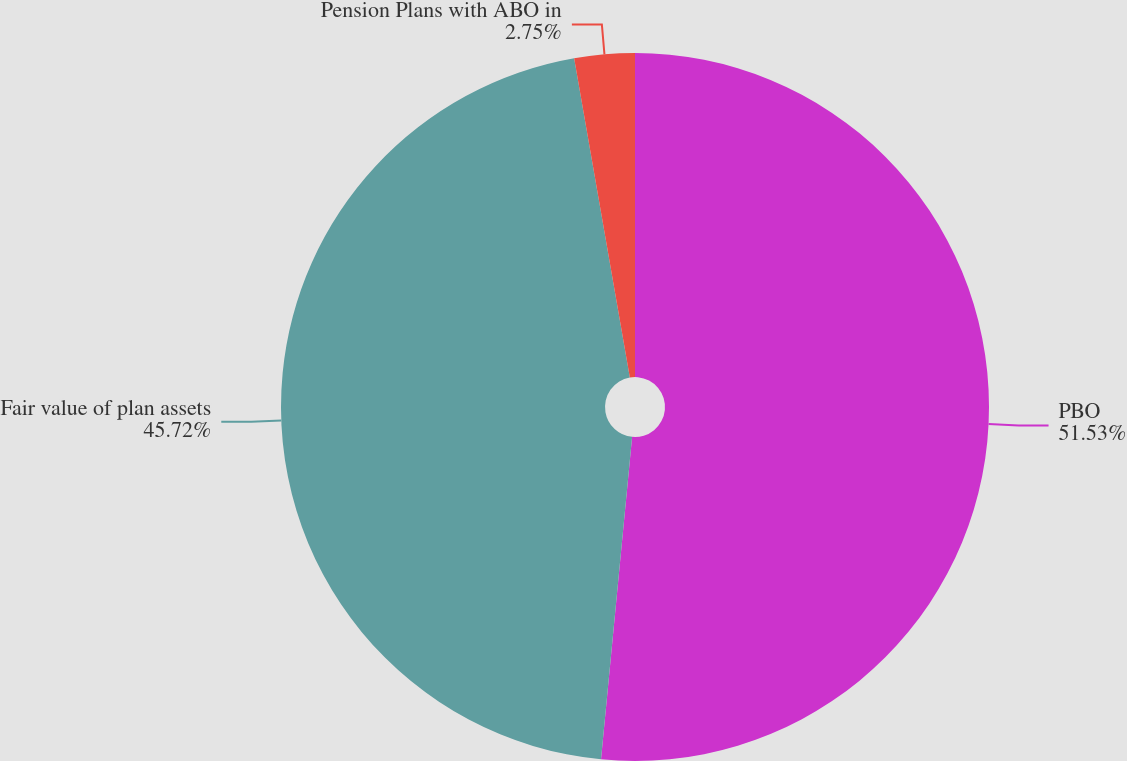Convert chart to OTSL. <chart><loc_0><loc_0><loc_500><loc_500><pie_chart><fcel>PBO<fcel>Fair value of plan assets<fcel>Pension Plans with ABO in<nl><fcel>51.53%<fcel>45.72%<fcel>2.75%<nl></chart> 